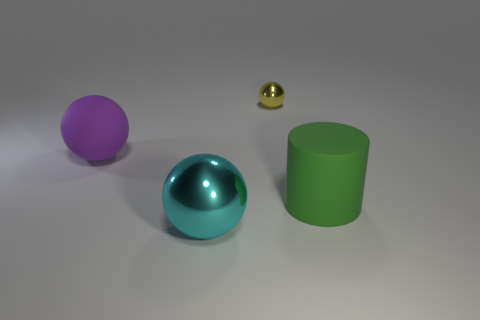Add 2 green cylinders. How many objects exist? 6 Subtract all cylinders. How many objects are left? 3 Subtract all tiny blue metal spheres. Subtract all yellow balls. How many objects are left? 3 Add 2 large spheres. How many large spheres are left? 4 Add 3 large cyan shiny spheres. How many large cyan shiny spheres exist? 4 Subtract 0 green balls. How many objects are left? 4 